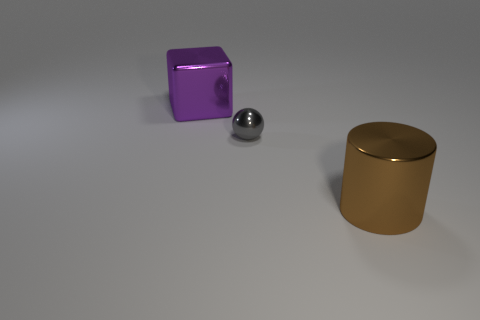There is a big shiny thing to the right of the cube; is it the same color as the small metal thing?
Provide a short and direct response. No. What number of shiny things are small spheres or big green cubes?
Make the answer very short. 1. What is the shape of the tiny object?
Make the answer very short. Sphere. Are there any other things that have the same material as the purple block?
Ensure brevity in your answer.  Yes. Are there any purple shiny blocks that are behind the big object left of the large shiny thing in front of the big cube?
Your answer should be very brief. No. How many other things are there of the same shape as the purple shiny thing?
Make the answer very short. 0. The metal thing that is behind the brown cylinder and in front of the large cube has what shape?
Give a very brief answer. Sphere. The large object that is behind the large thing that is in front of the shiny object that is behind the tiny metallic sphere is what color?
Your answer should be compact. Purple. Is the number of gray balls that are right of the tiny gray shiny ball greater than the number of big metallic cubes that are on the right side of the large metallic cube?
Your answer should be compact. No. What number of other objects are there of the same size as the purple cube?
Give a very brief answer. 1. 